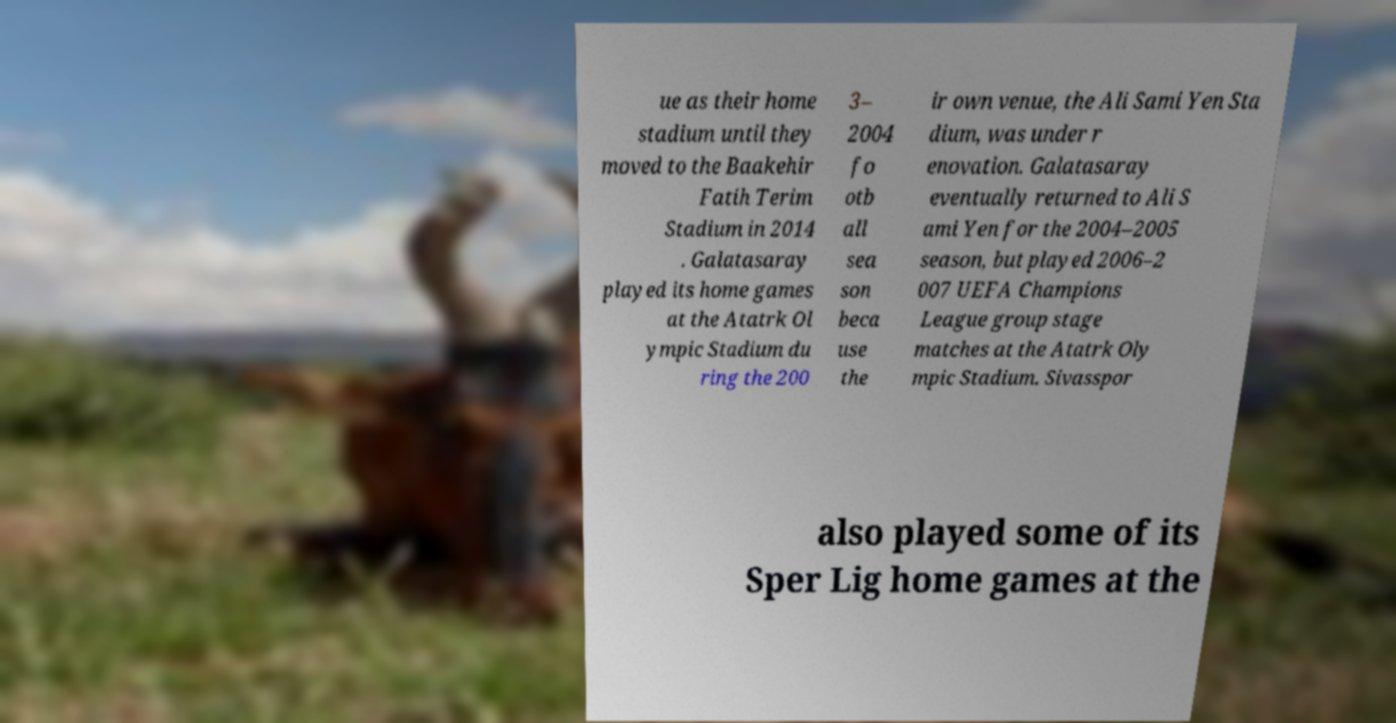Could you assist in decoding the text presented in this image and type it out clearly? ue as their home stadium until they moved to the Baakehir Fatih Terim Stadium in 2014 . Galatasaray played its home games at the Atatrk Ol ympic Stadium du ring the 200 3– 2004 fo otb all sea son beca use the ir own venue, the Ali Sami Yen Sta dium, was under r enovation. Galatasaray eventually returned to Ali S ami Yen for the 2004–2005 season, but played 2006–2 007 UEFA Champions League group stage matches at the Atatrk Oly mpic Stadium. Sivasspor also played some of its Sper Lig home games at the 